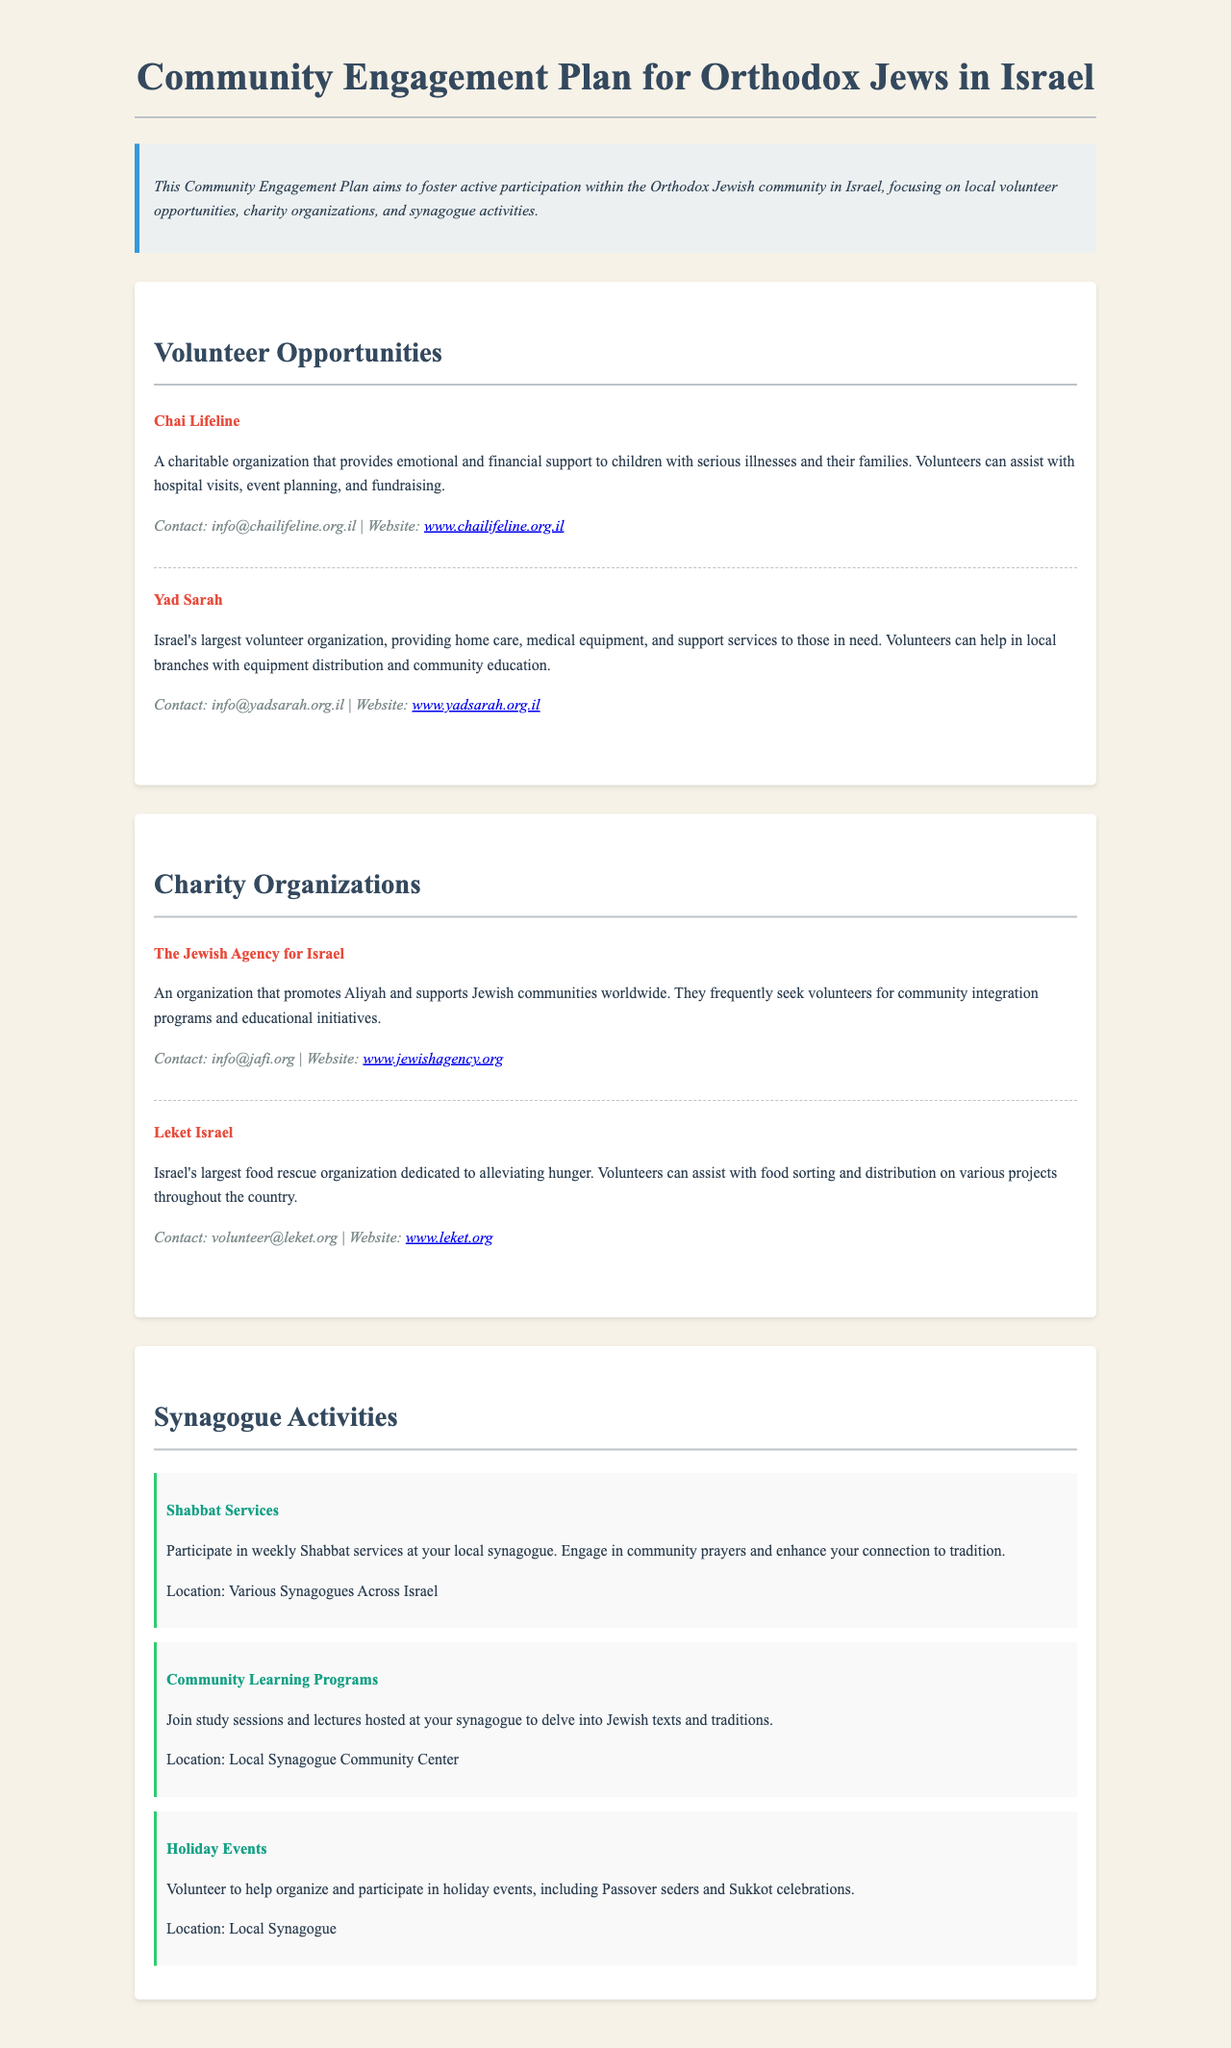What is the name of the charity organization providing support to children with serious illnesses? Chai Lifeline assists children with serious illnesses and their families.
Answer: Chai Lifeline How can one contact Yad Sarah? The contact information for Yad Sarah is provided for volunteers.
Answer: info@yadsarah.org.il What type of activities does Leket Israel focus on? Leket Israel is dedicated to alleviating hunger through food rescue initiatives.
Answer: Food rescue Where can community learning programs take place? Community learning programs are hosted at synagogues for studying Jewish texts.
Answer: Local Synagogue Community Center What is one opportunity to engage during Shabbat? Participating in Shabbat services is a way to engage with the community.
Answer: Shabbat Services How many volunteer organizations are mentioned in the document? The document lists multiple volunteer organizations for community engagement.
Answer: Four 